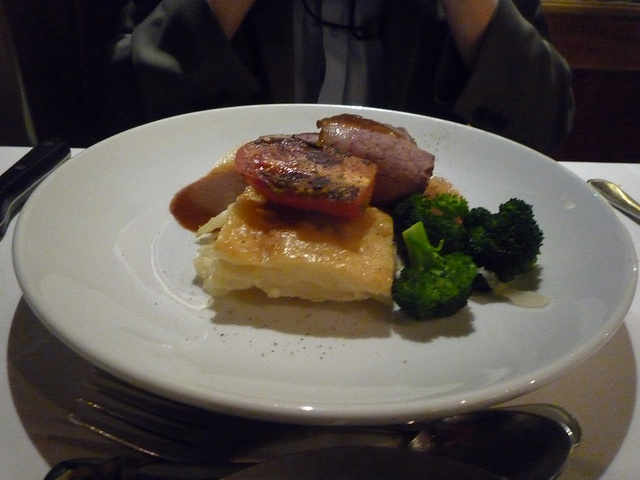Describe the objects in this image and their specific colors. I can see dining table in darkgray, black, gray, and maroon tones, people in black, maroon, and gray tones, spoon in black and gray tones, broccoli in black, darkgreen, and darkgray tones, and fork in black and gray tones in this image. 